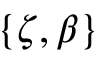Convert formula to latex. <formula><loc_0><loc_0><loc_500><loc_500>\left \{ \zeta , \beta \right \}</formula> 